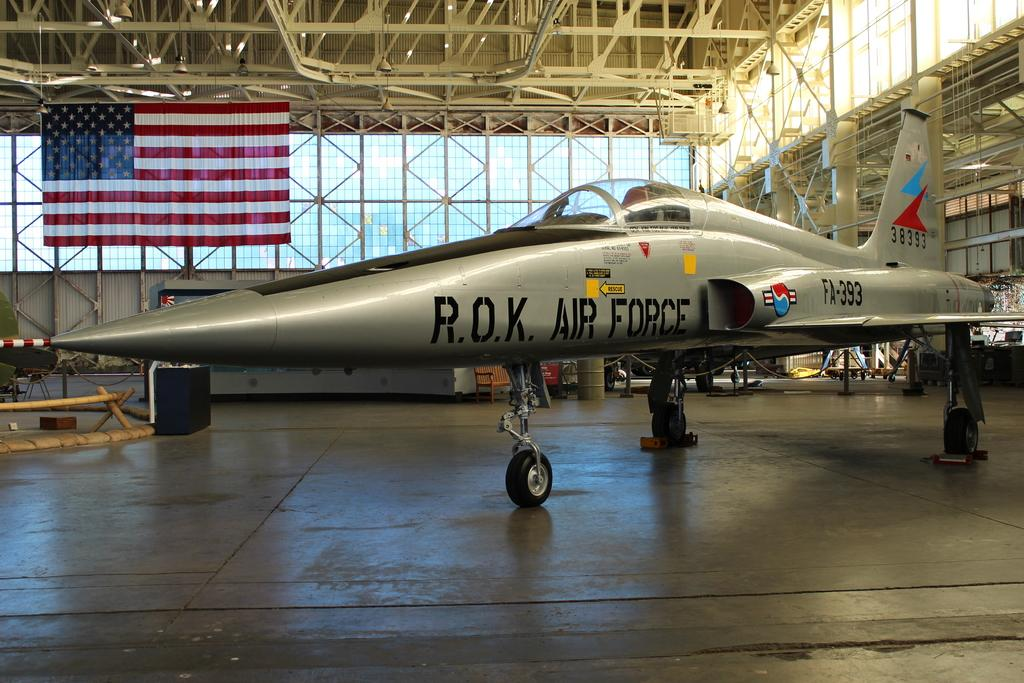<image>
Present a compact description of the photo's key features. R.O.K Air Force with a rescue arrow pointing left. 